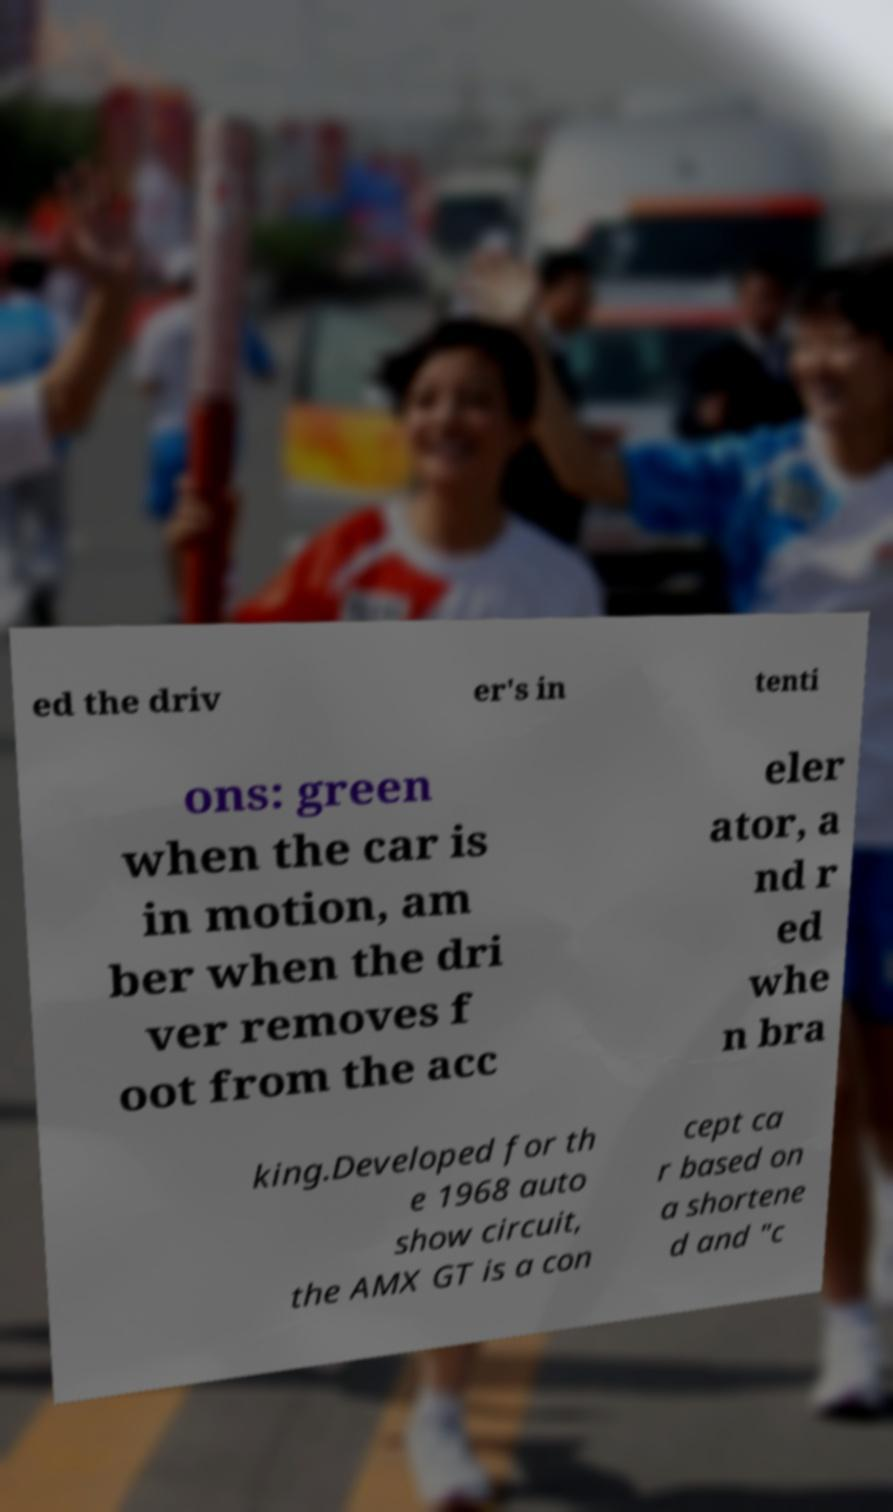There's text embedded in this image that I need extracted. Can you transcribe it verbatim? ed the driv er's in tenti ons: green when the car is in motion, am ber when the dri ver removes f oot from the acc eler ator, a nd r ed whe n bra king.Developed for th e 1968 auto show circuit, the AMX GT is a con cept ca r based on a shortene d and "c 